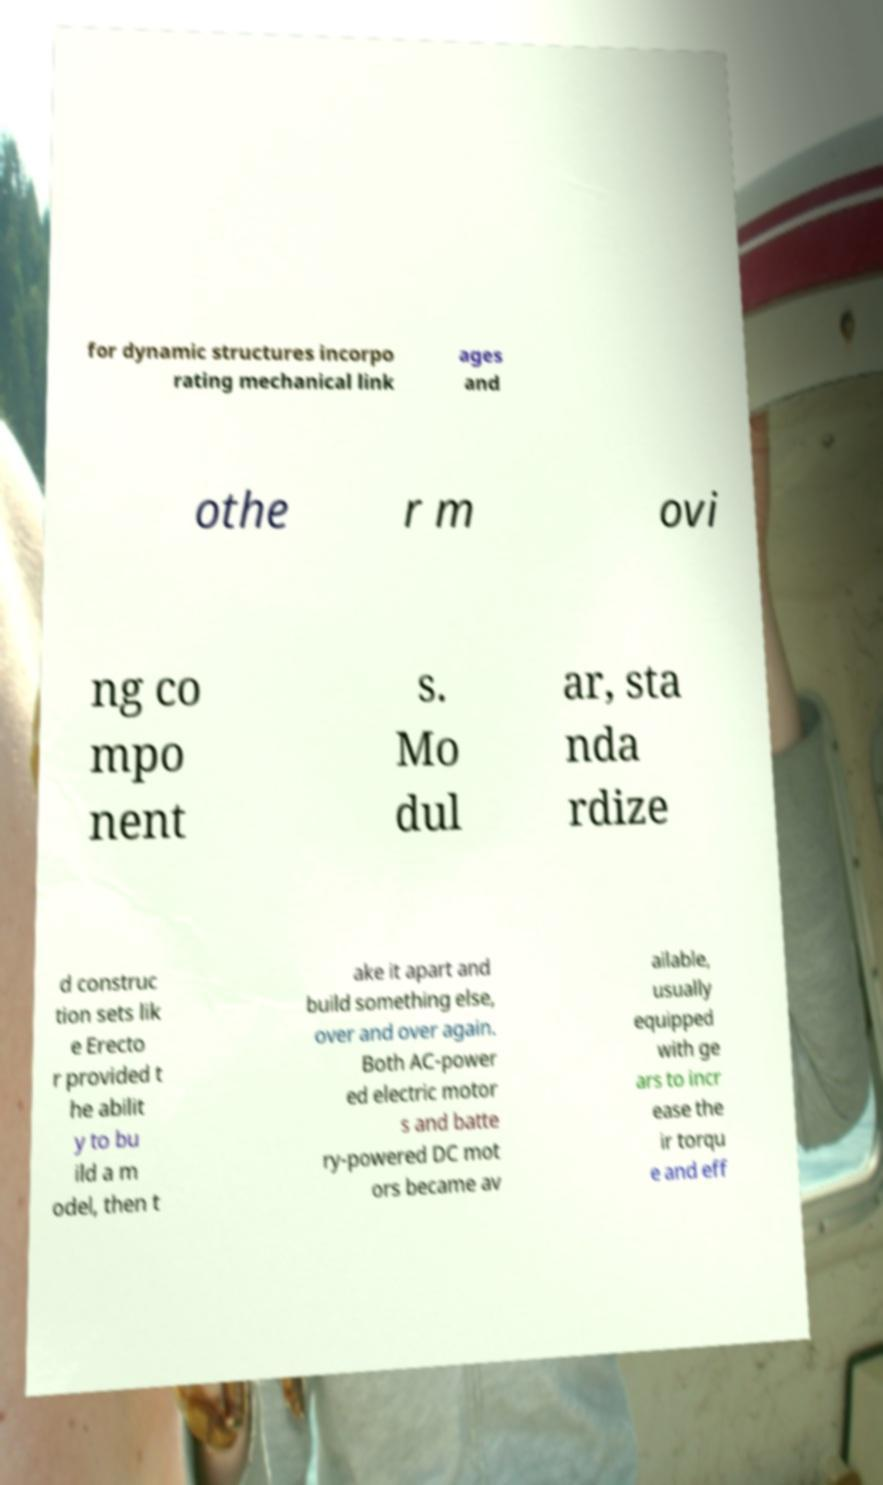For documentation purposes, I need the text within this image transcribed. Could you provide that? for dynamic structures incorpo rating mechanical link ages and othe r m ovi ng co mpo nent s. Mo dul ar, sta nda rdize d construc tion sets lik e Erecto r provided t he abilit y to bu ild a m odel, then t ake it apart and build something else, over and over again. Both AC-power ed electric motor s and batte ry-powered DC mot ors became av ailable, usually equipped with ge ars to incr ease the ir torqu e and eff 